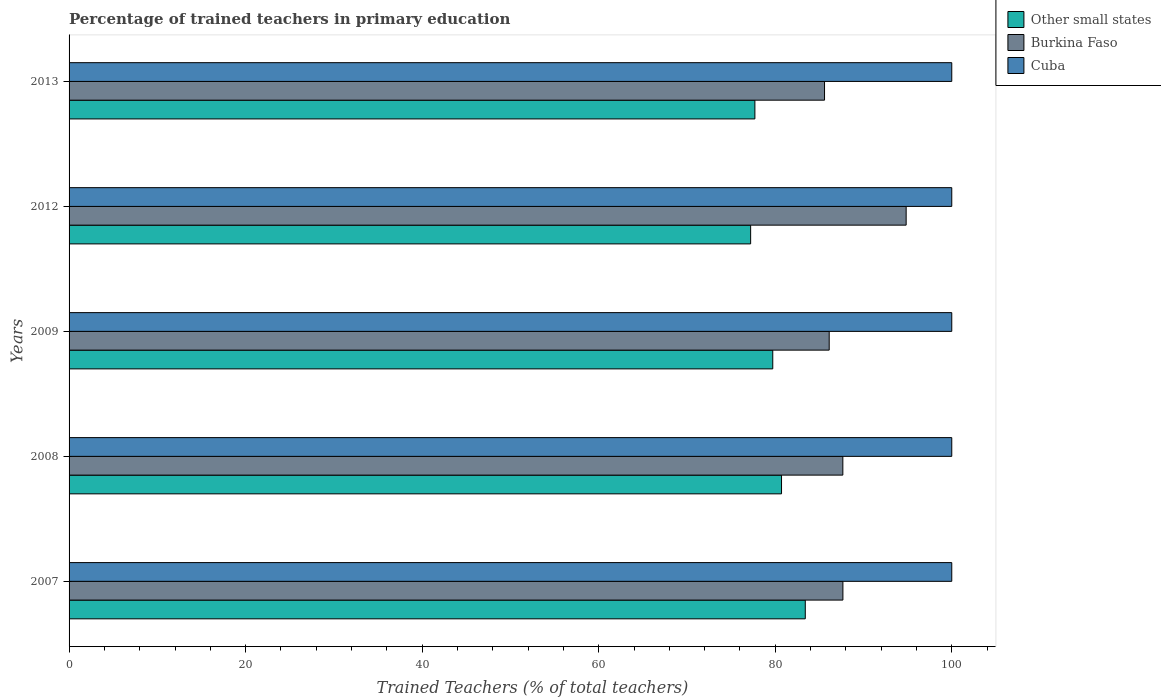How many groups of bars are there?
Provide a short and direct response. 5. How many bars are there on the 2nd tick from the top?
Offer a terse response. 3. How many bars are there on the 5th tick from the bottom?
Your answer should be very brief. 3. What is the label of the 2nd group of bars from the top?
Keep it short and to the point. 2012. What is the percentage of trained teachers in Other small states in 2009?
Offer a terse response. 79.72. Across all years, what is the maximum percentage of trained teachers in Burkina Faso?
Provide a short and direct response. 94.83. In which year was the percentage of trained teachers in Cuba minimum?
Give a very brief answer. 2007. What is the difference between the percentage of trained teachers in Burkina Faso in 2013 and the percentage of trained teachers in Other small states in 2012?
Offer a terse response. 8.37. In the year 2013, what is the difference between the percentage of trained teachers in Cuba and percentage of trained teachers in Other small states?
Offer a very short reply. 22.3. What is the ratio of the percentage of trained teachers in Other small states in 2007 to that in 2013?
Your response must be concise. 1.07. Is the difference between the percentage of trained teachers in Cuba in 2007 and 2009 greater than the difference between the percentage of trained teachers in Other small states in 2007 and 2009?
Give a very brief answer. No. What is the difference between the highest and the lowest percentage of trained teachers in Cuba?
Give a very brief answer. 0. What does the 3rd bar from the top in 2013 represents?
Give a very brief answer. Other small states. What does the 3rd bar from the bottom in 2007 represents?
Make the answer very short. Cuba. Is it the case that in every year, the sum of the percentage of trained teachers in Burkina Faso and percentage of trained teachers in Other small states is greater than the percentage of trained teachers in Cuba?
Give a very brief answer. Yes. How many bars are there?
Offer a very short reply. 15. Are the values on the major ticks of X-axis written in scientific E-notation?
Make the answer very short. No. Does the graph contain any zero values?
Make the answer very short. No. What is the title of the graph?
Give a very brief answer. Percentage of trained teachers in primary education. What is the label or title of the X-axis?
Your answer should be very brief. Trained Teachers (% of total teachers). What is the label or title of the Y-axis?
Your response must be concise. Years. What is the Trained Teachers (% of total teachers) of Other small states in 2007?
Give a very brief answer. 83.4. What is the Trained Teachers (% of total teachers) in Burkina Faso in 2007?
Your response must be concise. 87.67. What is the Trained Teachers (% of total teachers) of Other small states in 2008?
Your answer should be very brief. 80.71. What is the Trained Teachers (% of total teachers) in Burkina Faso in 2008?
Ensure brevity in your answer.  87.66. What is the Trained Teachers (% of total teachers) in Cuba in 2008?
Ensure brevity in your answer.  100. What is the Trained Teachers (% of total teachers) of Other small states in 2009?
Provide a succinct answer. 79.72. What is the Trained Teachers (% of total teachers) in Burkina Faso in 2009?
Your answer should be very brief. 86.11. What is the Trained Teachers (% of total teachers) of Cuba in 2009?
Your response must be concise. 100. What is the Trained Teachers (% of total teachers) of Other small states in 2012?
Offer a very short reply. 77.22. What is the Trained Teachers (% of total teachers) of Burkina Faso in 2012?
Your answer should be compact. 94.83. What is the Trained Teachers (% of total teachers) of Other small states in 2013?
Provide a short and direct response. 77.7. What is the Trained Teachers (% of total teachers) in Burkina Faso in 2013?
Your response must be concise. 85.59. Across all years, what is the maximum Trained Teachers (% of total teachers) in Other small states?
Provide a short and direct response. 83.4. Across all years, what is the maximum Trained Teachers (% of total teachers) of Burkina Faso?
Give a very brief answer. 94.83. Across all years, what is the maximum Trained Teachers (% of total teachers) in Cuba?
Ensure brevity in your answer.  100. Across all years, what is the minimum Trained Teachers (% of total teachers) of Other small states?
Offer a terse response. 77.22. Across all years, what is the minimum Trained Teachers (% of total teachers) in Burkina Faso?
Provide a succinct answer. 85.59. What is the total Trained Teachers (% of total teachers) of Other small states in the graph?
Offer a terse response. 398.75. What is the total Trained Teachers (% of total teachers) in Burkina Faso in the graph?
Make the answer very short. 441.86. What is the total Trained Teachers (% of total teachers) of Cuba in the graph?
Your answer should be compact. 500. What is the difference between the Trained Teachers (% of total teachers) of Other small states in 2007 and that in 2008?
Ensure brevity in your answer.  2.69. What is the difference between the Trained Teachers (% of total teachers) in Burkina Faso in 2007 and that in 2008?
Ensure brevity in your answer.  0.01. What is the difference between the Trained Teachers (% of total teachers) in Cuba in 2007 and that in 2008?
Your answer should be compact. 0. What is the difference between the Trained Teachers (% of total teachers) of Other small states in 2007 and that in 2009?
Provide a short and direct response. 3.68. What is the difference between the Trained Teachers (% of total teachers) in Burkina Faso in 2007 and that in 2009?
Your answer should be very brief. 1.55. What is the difference between the Trained Teachers (% of total teachers) of Other small states in 2007 and that in 2012?
Your response must be concise. 6.19. What is the difference between the Trained Teachers (% of total teachers) of Burkina Faso in 2007 and that in 2012?
Offer a terse response. -7.16. What is the difference between the Trained Teachers (% of total teachers) in Cuba in 2007 and that in 2012?
Make the answer very short. 0. What is the difference between the Trained Teachers (% of total teachers) in Other small states in 2007 and that in 2013?
Ensure brevity in your answer.  5.71. What is the difference between the Trained Teachers (% of total teachers) in Burkina Faso in 2007 and that in 2013?
Provide a succinct answer. 2.08. What is the difference between the Trained Teachers (% of total teachers) of Other small states in 2008 and that in 2009?
Make the answer very short. 0.99. What is the difference between the Trained Teachers (% of total teachers) of Burkina Faso in 2008 and that in 2009?
Offer a terse response. 1.55. What is the difference between the Trained Teachers (% of total teachers) of Cuba in 2008 and that in 2009?
Make the answer very short. 0. What is the difference between the Trained Teachers (% of total teachers) in Other small states in 2008 and that in 2012?
Your response must be concise. 3.5. What is the difference between the Trained Teachers (% of total teachers) in Burkina Faso in 2008 and that in 2012?
Make the answer very short. -7.17. What is the difference between the Trained Teachers (% of total teachers) of Cuba in 2008 and that in 2012?
Keep it short and to the point. 0. What is the difference between the Trained Teachers (% of total teachers) in Other small states in 2008 and that in 2013?
Ensure brevity in your answer.  3.02. What is the difference between the Trained Teachers (% of total teachers) in Burkina Faso in 2008 and that in 2013?
Offer a terse response. 2.07. What is the difference between the Trained Teachers (% of total teachers) in Cuba in 2008 and that in 2013?
Provide a short and direct response. 0. What is the difference between the Trained Teachers (% of total teachers) in Other small states in 2009 and that in 2012?
Provide a succinct answer. 2.51. What is the difference between the Trained Teachers (% of total teachers) of Burkina Faso in 2009 and that in 2012?
Make the answer very short. -8.72. What is the difference between the Trained Teachers (% of total teachers) in Other small states in 2009 and that in 2013?
Your answer should be compact. 2.02. What is the difference between the Trained Teachers (% of total teachers) of Burkina Faso in 2009 and that in 2013?
Your answer should be very brief. 0.53. What is the difference between the Trained Teachers (% of total teachers) of Cuba in 2009 and that in 2013?
Provide a succinct answer. 0. What is the difference between the Trained Teachers (% of total teachers) of Other small states in 2012 and that in 2013?
Your response must be concise. -0.48. What is the difference between the Trained Teachers (% of total teachers) in Burkina Faso in 2012 and that in 2013?
Your answer should be compact. 9.25. What is the difference between the Trained Teachers (% of total teachers) of Other small states in 2007 and the Trained Teachers (% of total teachers) of Burkina Faso in 2008?
Give a very brief answer. -4.26. What is the difference between the Trained Teachers (% of total teachers) of Other small states in 2007 and the Trained Teachers (% of total teachers) of Cuba in 2008?
Your response must be concise. -16.6. What is the difference between the Trained Teachers (% of total teachers) of Burkina Faso in 2007 and the Trained Teachers (% of total teachers) of Cuba in 2008?
Offer a very short reply. -12.33. What is the difference between the Trained Teachers (% of total teachers) in Other small states in 2007 and the Trained Teachers (% of total teachers) in Burkina Faso in 2009?
Give a very brief answer. -2.71. What is the difference between the Trained Teachers (% of total teachers) of Other small states in 2007 and the Trained Teachers (% of total teachers) of Cuba in 2009?
Keep it short and to the point. -16.6. What is the difference between the Trained Teachers (% of total teachers) of Burkina Faso in 2007 and the Trained Teachers (% of total teachers) of Cuba in 2009?
Your answer should be very brief. -12.33. What is the difference between the Trained Teachers (% of total teachers) in Other small states in 2007 and the Trained Teachers (% of total teachers) in Burkina Faso in 2012?
Your answer should be compact. -11.43. What is the difference between the Trained Teachers (% of total teachers) of Other small states in 2007 and the Trained Teachers (% of total teachers) of Cuba in 2012?
Provide a succinct answer. -16.6. What is the difference between the Trained Teachers (% of total teachers) in Burkina Faso in 2007 and the Trained Teachers (% of total teachers) in Cuba in 2012?
Your answer should be compact. -12.33. What is the difference between the Trained Teachers (% of total teachers) of Other small states in 2007 and the Trained Teachers (% of total teachers) of Burkina Faso in 2013?
Provide a short and direct response. -2.18. What is the difference between the Trained Teachers (% of total teachers) in Other small states in 2007 and the Trained Teachers (% of total teachers) in Cuba in 2013?
Offer a terse response. -16.6. What is the difference between the Trained Teachers (% of total teachers) in Burkina Faso in 2007 and the Trained Teachers (% of total teachers) in Cuba in 2013?
Offer a very short reply. -12.33. What is the difference between the Trained Teachers (% of total teachers) in Other small states in 2008 and the Trained Teachers (% of total teachers) in Burkina Faso in 2009?
Your answer should be compact. -5.4. What is the difference between the Trained Teachers (% of total teachers) of Other small states in 2008 and the Trained Teachers (% of total teachers) of Cuba in 2009?
Give a very brief answer. -19.29. What is the difference between the Trained Teachers (% of total teachers) of Burkina Faso in 2008 and the Trained Teachers (% of total teachers) of Cuba in 2009?
Your answer should be compact. -12.34. What is the difference between the Trained Teachers (% of total teachers) of Other small states in 2008 and the Trained Teachers (% of total teachers) of Burkina Faso in 2012?
Your response must be concise. -14.12. What is the difference between the Trained Teachers (% of total teachers) of Other small states in 2008 and the Trained Teachers (% of total teachers) of Cuba in 2012?
Your response must be concise. -19.29. What is the difference between the Trained Teachers (% of total teachers) in Burkina Faso in 2008 and the Trained Teachers (% of total teachers) in Cuba in 2012?
Your answer should be very brief. -12.34. What is the difference between the Trained Teachers (% of total teachers) of Other small states in 2008 and the Trained Teachers (% of total teachers) of Burkina Faso in 2013?
Your response must be concise. -4.87. What is the difference between the Trained Teachers (% of total teachers) in Other small states in 2008 and the Trained Teachers (% of total teachers) in Cuba in 2013?
Your response must be concise. -19.29. What is the difference between the Trained Teachers (% of total teachers) in Burkina Faso in 2008 and the Trained Teachers (% of total teachers) in Cuba in 2013?
Provide a short and direct response. -12.34. What is the difference between the Trained Teachers (% of total teachers) in Other small states in 2009 and the Trained Teachers (% of total teachers) in Burkina Faso in 2012?
Ensure brevity in your answer.  -15.11. What is the difference between the Trained Teachers (% of total teachers) of Other small states in 2009 and the Trained Teachers (% of total teachers) of Cuba in 2012?
Your answer should be compact. -20.28. What is the difference between the Trained Teachers (% of total teachers) in Burkina Faso in 2009 and the Trained Teachers (% of total teachers) in Cuba in 2012?
Give a very brief answer. -13.89. What is the difference between the Trained Teachers (% of total teachers) in Other small states in 2009 and the Trained Teachers (% of total teachers) in Burkina Faso in 2013?
Provide a short and direct response. -5.87. What is the difference between the Trained Teachers (% of total teachers) of Other small states in 2009 and the Trained Teachers (% of total teachers) of Cuba in 2013?
Offer a terse response. -20.28. What is the difference between the Trained Teachers (% of total teachers) of Burkina Faso in 2009 and the Trained Teachers (% of total teachers) of Cuba in 2013?
Offer a terse response. -13.89. What is the difference between the Trained Teachers (% of total teachers) of Other small states in 2012 and the Trained Teachers (% of total teachers) of Burkina Faso in 2013?
Provide a short and direct response. -8.37. What is the difference between the Trained Teachers (% of total teachers) of Other small states in 2012 and the Trained Teachers (% of total teachers) of Cuba in 2013?
Your response must be concise. -22.78. What is the difference between the Trained Teachers (% of total teachers) in Burkina Faso in 2012 and the Trained Teachers (% of total teachers) in Cuba in 2013?
Your response must be concise. -5.17. What is the average Trained Teachers (% of total teachers) in Other small states per year?
Offer a very short reply. 79.75. What is the average Trained Teachers (% of total teachers) in Burkina Faso per year?
Provide a short and direct response. 88.37. What is the average Trained Teachers (% of total teachers) in Cuba per year?
Offer a very short reply. 100. In the year 2007, what is the difference between the Trained Teachers (% of total teachers) of Other small states and Trained Teachers (% of total teachers) of Burkina Faso?
Offer a very short reply. -4.26. In the year 2007, what is the difference between the Trained Teachers (% of total teachers) in Other small states and Trained Teachers (% of total teachers) in Cuba?
Make the answer very short. -16.6. In the year 2007, what is the difference between the Trained Teachers (% of total teachers) in Burkina Faso and Trained Teachers (% of total teachers) in Cuba?
Provide a short and direct response. -12.33. In the year 2008, what is the difference between the Trained Teachers (% of total teachers) in Other small states and Trained Teachers (% of total teachers) in Burkina Faso?
Offer a very short reply. -6.95. In the year 2008, what is the difference between the Trained Teachers (% of total teachers) of Other small states and Trained Teachers (% of total teachers) of Cuba?
Offer a very short reply. -19.29. In the year 2008, what is the difference between the Trained Teachers (% of total teachers) of Burkina Faso and Trained Teachers (% of total teachers) of Cuba?
Offer a terse response. -12.34. In the year 2009, what is the difference between the Trained Teachers (% of total teachers) of Other small states and Trained Teachers (% of total teachers) of Burkina Faso?
Your answer should be compact. -6.39. In the year 2009, what is the difference between the Trained Teachers (% of total teachers) in Other small states and Trained Teachers (% of total teachers) in Cuba?
Ensure brevity in your answer.  -20.28. In the year 2009, what is the difference between the Trained Teachers (% of total teachers) of Burkina Faso and Trained Teachers (% of total teachers) of Cuba?
Keep it short and to the point. -13.89. In the year 2012, what is the difference between the Trained Teachers (% of total teachers) of Other small states and Trained Teachers (% of total teachers) of Burkina Faso?
Provide a succinct answer. -17.62. In the year 2012, what is the difference between the Trained Teachers (% of total teachers) in Other small states and Trained Teachers (% of total teachers) in Cuba?
Your answer should be compact. -22.78. In the year 2012, what is the difference between the Trained Teachers (% of total teachers) in Burkina Faso and Trained Teachers (% of total teachers) in Cuba?
Ensure brevity in your answer.  -5.17. In the year 2013, what is the difference between the Trained Teachers (% of total teachers) in Other small states and Trained Teachers (% of total teachers) in Burkina Faso?
Provide a succinct answer. -7.89. In the year 2013, what is the difference between the Trained Teachers (% of total teachers) of Other small states and Trained Teachers (% of total teachers) of Cuba?
Your response must be concise. -22.3. In the year 2013, what is the difference between the Trained Teachers (% of total teachers) in Burkina Faso and Trained Teachers (% of total teachers) in Cuba?
Provide a succinct answer. -14.41. What is the ratio of the Trained Teachers (% of total teachers) in Burkina Faso in 2007 to that in 2008?
Your answer should be very brief. 1. What is the ratio of the Trained Teachers (% of total teachers) in Other small states in 2007 to that in 2009?
Your response must be concise. 1.05. What is the ratio of the Trained Teachers (% of total teachers) of Other small states in 2007 to that in 2012?
Provide a short and direct response. 1.08. What is the ratio of the Trained Teachers (% of total teachers) in Burkina Faso in 2007 to that in 2012?
Your response must be concise. 0.92. What is the ratio of the Trained Teachers (% of total teachers) of Other small states in 2007 to that in 2013?
Your answer should be compact. 1.07. What is the ratio of the Trained Teachers (% of total teachers) in Burkina Faso in 2007 to that in 2013?
Offer a terse response. 1.02. What is the ratio of the Trained Teachers (% of total teachers) in Other small states in 2008 to that in 2009?
Your response must be concise. 1.01. What is the ratio of the Trained Teachers (% of total teachers) of Cuba in 2008 to that in 2009?
Offer a terse response. 1. What is the ratio of the Trained Teachers (% of total teachers) of Other small states in 2008 to that in 2012?
Keep it short and to the point. 1.05. What is the ratio of the Trained Teachers (% of total teachers) in Burkina Faso in 2008 to that in 2012?
Your answer should be compact. 0.92. What is the ratio of the Trained Teachers (% of total teachers) of Other small states in 2008 to that in 2013?
Your answer should be very brief. 1.04. What is the ratio of the Trained Teachers (% of total teachers) in Burkina Faso in 2008 to that in 2013?
Make the answer very short. 1.02. What is the ratio of the Trained Teachers (% of total teachers) in Cuba in 2008 to that in 2013?
Provide a succinct answer. 1. What is the ratio of the Trained Teachers (% of total teachers) of Other small states in 2009 to that in 2012?
Provide a succinct answer. 1.03. What is the ratio of the Trained Teachers (% of total teachers) in Burkina Faso in 2009 to that in 2012?
Your response must be concise. 0.91. What is the ratio of the Trained Teachers (% of total teachers) in Other small states in 2009 to that in 2013?
Keep it short and to the point. 1.03. What is the ratio of the Trained Teachers (% of total teachers) of Cuba in 2009 to that in 2013?
Provide a short and direct response. 1. What is the ratio of the Trained Teachers (% of total teachers) of Other small states in 2012 to that in 2013?
Give a very brief answer. 0.99. What is the ratio of the Trained Teachers (% of total teachers) in Burkina Faso in 2012 to that in 2013?
Ensure brevity in your answer.  1.11. What is the difference between the highest and the second highest Trained Teachers (% of total teachers) in Other small states?
Provide a short and direct response. 2.69. What is the difference between the highest and the second highest Trained Teachers (% of total teachers) of Burkina Faso?
Make the answer very short. 7.16. What is the difference between the highest and the lowest Trained Teachers (% of total teachers) of Other small states?
Give a very brief answer. 6.19. What is the difference between the highest and the lowest Trained Teachers (% of total teachers) of Burkina Faso?
Offer a very short reply. 9.25. What is the difference between the highest and the lowest Trained Teachers (% of total teachers) in Cuba?
Give a very brief answer. 0. 